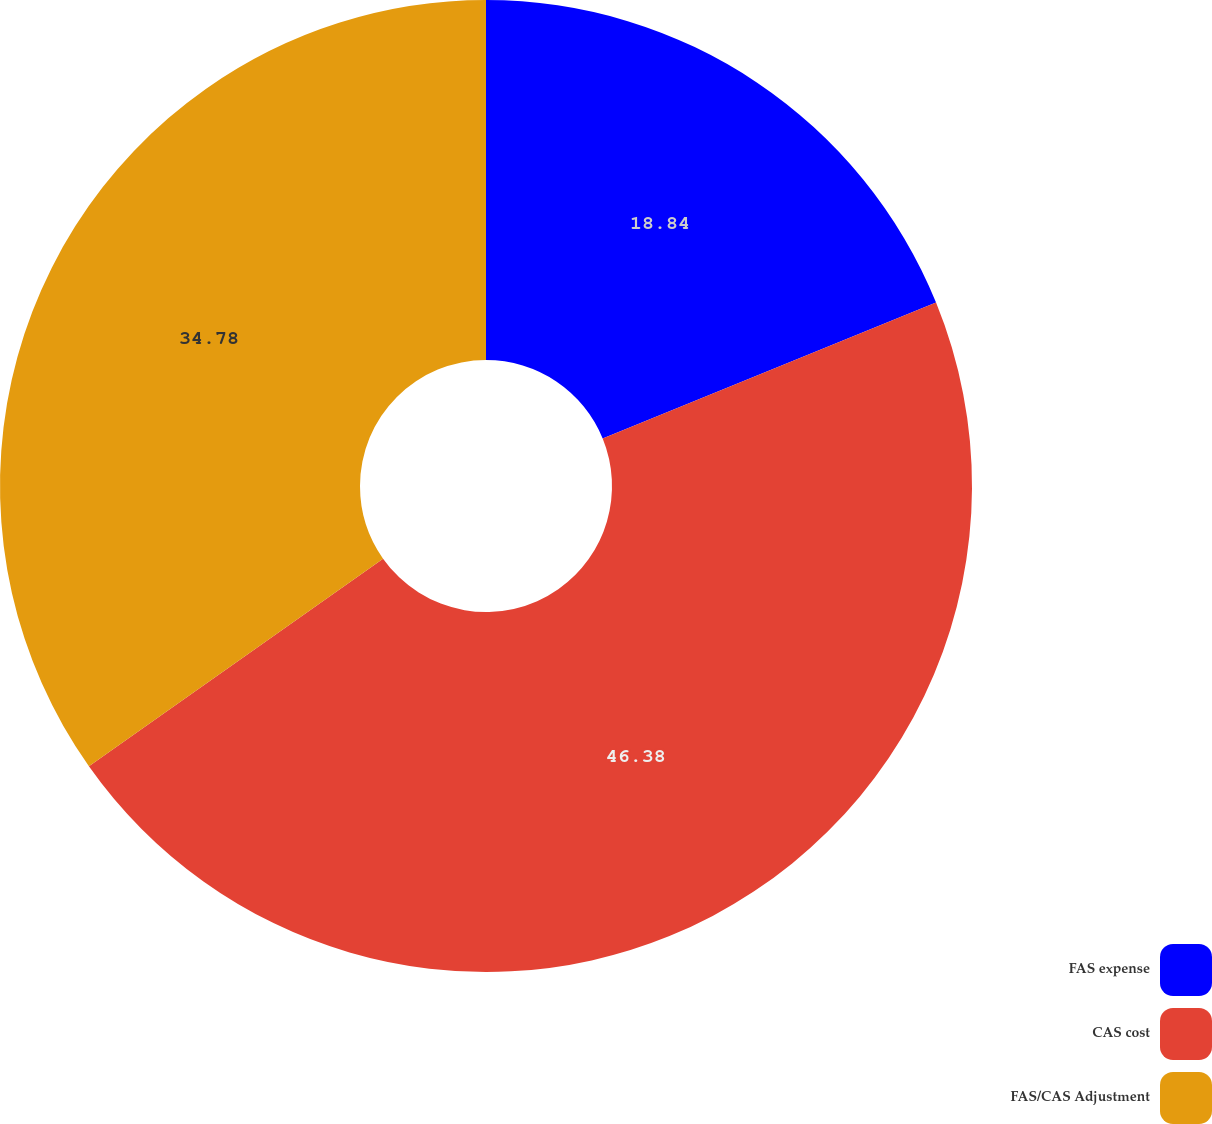<chart> <loc_0><loc_0><loc_500><loc_500><pie_chart><fcel>FAS expense<fcel>CAS cost<fcel>FAS/CAS Adjustment<nl><fcel>18.84%<fcel>46.38%<fcel>34.78%<nl></chart> 